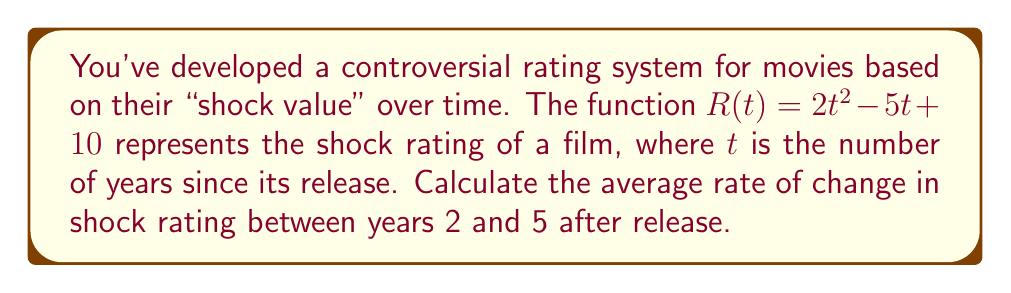Give your solution to this math problem. To find the average rate of change between two points, we use the formula:

$$\text{Average rate of change} = \frac{f(b) - f(a)}{b - a}$$

Where $a$ and $b$ are the start and end points of the interval.

1) First, calculate $R(2)$:
   $R(2) = 2(2)^2 - 5(2) + 10 = 2(4) - 10 + 10 = 8$

2) Next, calculate $R(5)$:
   $R(5) = 2(5)^2 - 5(5) + 10 = 2(25) - 25 + 10 = 35$

3) Now, apply the average rate of change formula:
   $$\text{Average rate of change} = \frac{R(5) - R(2)}{5 - 2} = \frac{35 - 8}{3} = \frac{27}{3} = 9$$

Therefore, the average rate of change in shock rating between years 2 and 5 after release is 9 units per year.
Answer: 9 units/year 